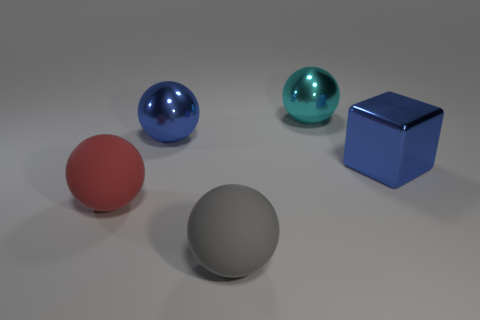Subtract all large gray spheres. How many spheres are left? 3 Subtract all red balls. How many balls are left? 3 Add 1 blue metal things. How many objects exist? 6 Subtract all green balls. Subtract all gray blocks. How many balls are left? 4 Subtract all spheres. How many objects are left? 1 Subtract 0 red cylinders. How many objects are left? 5 Subtract all tiny yellow matte balls. Subtract all cyan metal objects. How many objects are left? 4 Add 5 big blue objects. How many big blue objects are left? 7 Add 4 big things. How many big things exist? 9 